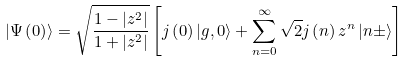Convert formula to latex. <formula><loc_0><loc_0><loc_500><loc_500>\left | \Psi \left ( 0 \right ) \right \rangle = \sqrt { \frac { 1 - \left | z ^ { 2 } \right | } { 1 + \left | z ^ { 2 } \right | } } \left [ j \left ( 0 \right ) \left | g , 0 \right \rangle + \sum _ { n = 0 } ^ { \infty } \sqrt { 2 } j \left ( n \right ) z ^ { n } \left | n \pm \right \rangle \right ]</formula> 